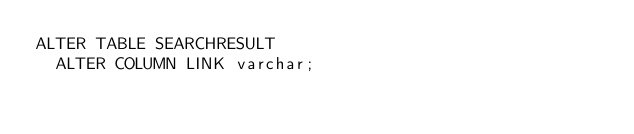<code> <loc_0><loc_0><loc_500><loc_500><_SQL_>ALTER TABLE SEARCHRESULT
  ALTER COLUMN LINK varchar;</code> 